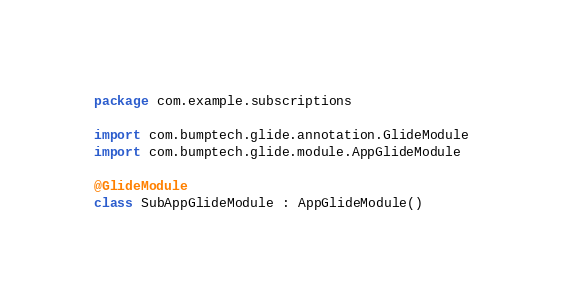<code> <loc_0><loc_0><loc_500><loc_500><_Kotlin_>package com.example.subscriptions

import com.bumptech.glide.annotation.GlideModule
import com.bumptech.glide.module.AppGlideModule

@GlideModule
class SubAppGlideModule : AppGlideModule()</code> 